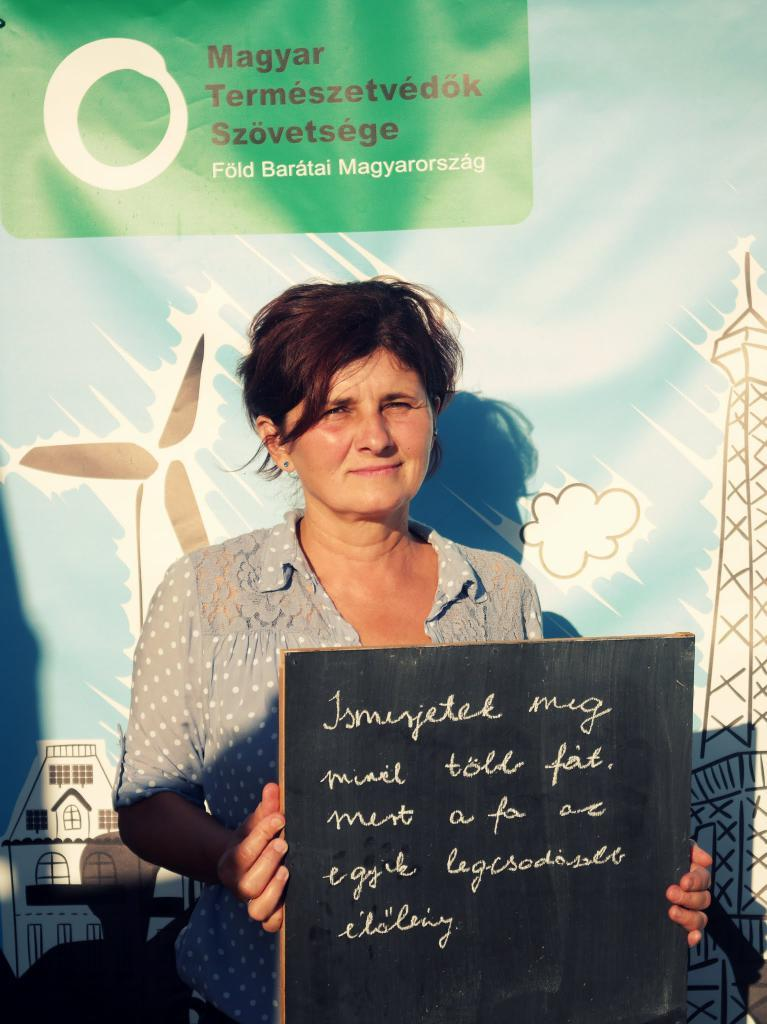Who is the main subject in the image? There is a woman in the image. What is the woman doing in the image? The woman is standing in the front and smiling. What is the woman holding in her hand? The woman is holding a board in her hand. What can be seen in the background of the image? There is a blue color banner in the background of the image. What type of space exploration equipment can be seen in the image? There is no space exploration equipment present in the image. What form does the zinc take in the image? There is no zinc present in the image. 